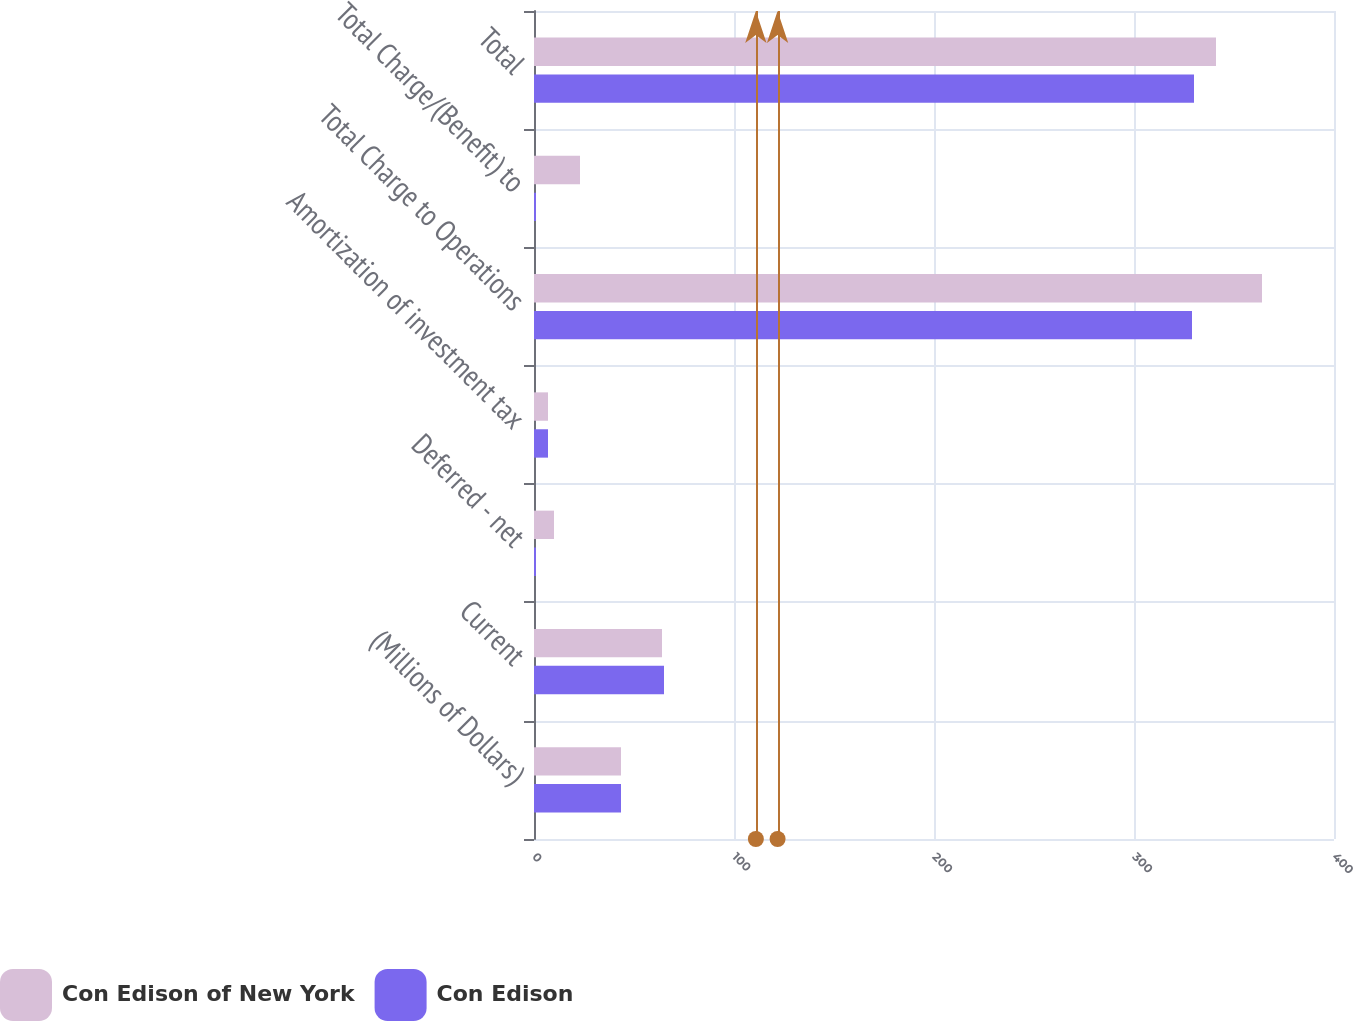Convert chart to OTSL. <chart><loc_0><loc_0><loc_500><loc_500><stacked_bar_chart><ecel><fcel>(Millions of Dollars)<fcel>Current<fcel>Deferred - net<fcel>Amortization of investment tax<fcel>Total Charge to Operations<fcel>Total Charge/(Benefit) to<fcel>Total<nl><fcel>Con Edison of New York<fcel>43.5<fcel>64<fcel>10<fcel>7<fcel>364<fcel>23<fcel>341<nl><fcel>Con Edison<fcel>43.5<fcel>65<fcel>1<fcel>7<fcel>329<fcel>1<fcel>330<nl></chart> 